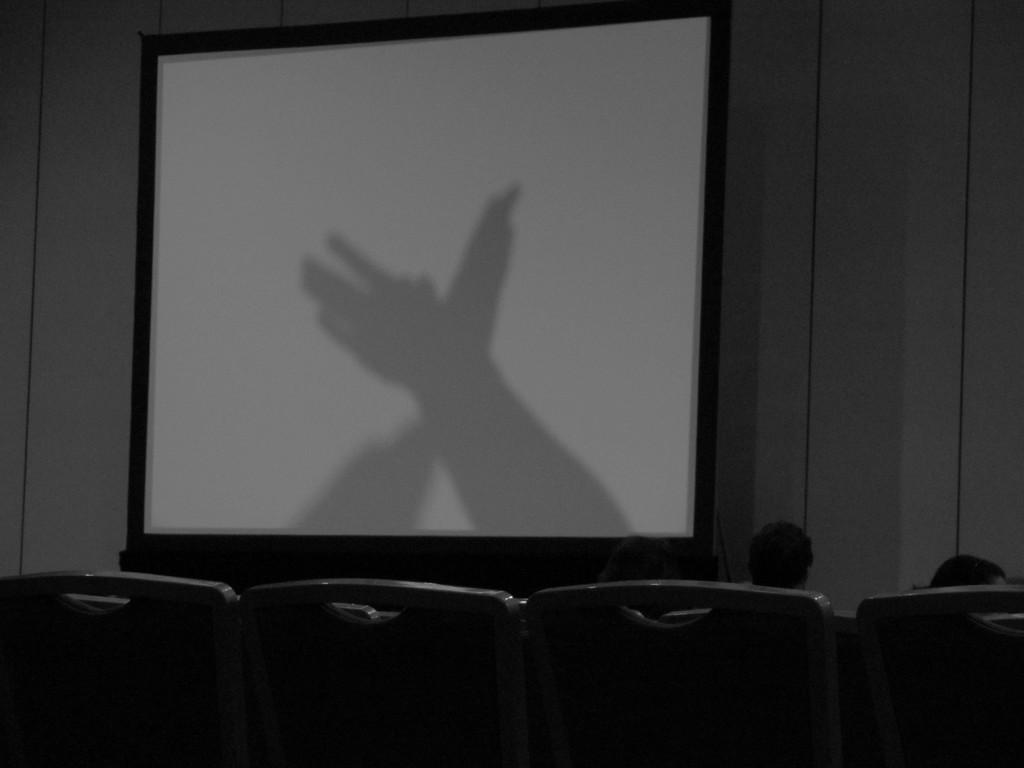Please provide a concise description of this image. In this image there are some chairs on the bottom of this image and there are some persons sitting on these chairs. There is a screen in middle of this image and there is a wall in the background. 